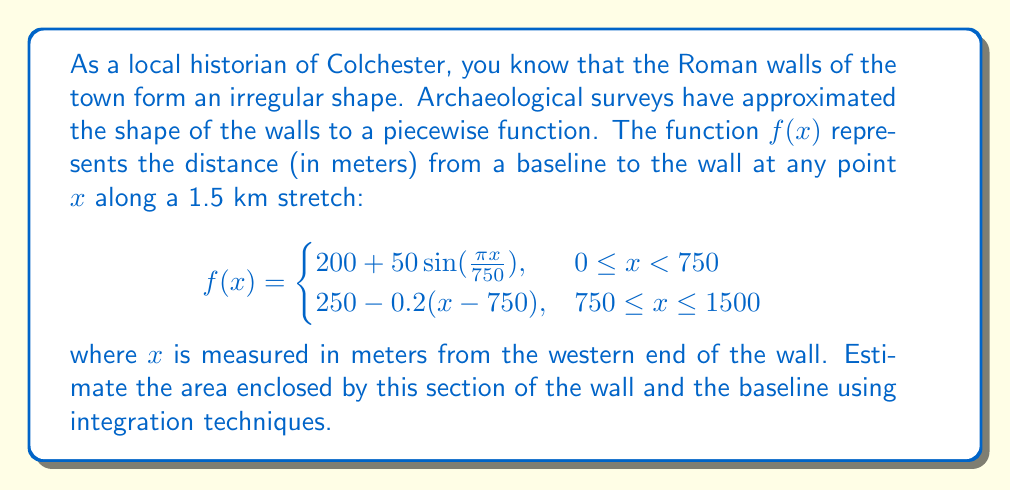Could you help me with this problem? To estimate the area enclosed by the wall and the baseline, we need to integrate the piecewise function $f(x)$ over the interval $[0, 1500]$. We'll split this into two integrals corresponding to the two pieces of the function:

1. For $0 \leq x < 750$:
   $$\int_0^{750} (200 + 50\sin(\frac{\pi x}{750})) dx$$

2. For $750 \leq x \leq 1500$:
   $$\int_{750}^{1500} (250 - 0.2(x-750)) dx$$

Let's evaluate each integral:

1. $$\begin{aligned}
   \int_0^{750} (200 + 50\sin(\frac{\pi x}{750})) dx &= 200x - \frac{50 \cdot 750}{\pi} \cos(\frac{\pi x}{750}) \bigg|_0^{750} \\
   &= 150000 - \frac{37500}{\pi} \cos(\pi) + \frac{37500}{\pi} \\
   &= 150000 + \frac{75000}{\pi} \approx 173917.31
   \end{aligned}$$

2. $$\begin{aligned}
   \int_{750}^{1500} (250 - 0.2(x-750)) dx &= 250x - 0.1(x-750)^2 \bigg|_{750}^{1500} \\
   &= (375000 - 56250) - (187500 - 0) \\
   &= 131250
   \end{aligned}$$

The total area is the sum of these two integrals:
$$173917.31 + 131250 = 305167.31 \text{ square meters}$$
Answer: The estimated area enclosed by this section of Colchester's Roman wall and the baseline is approximately 305,167 square meters. 